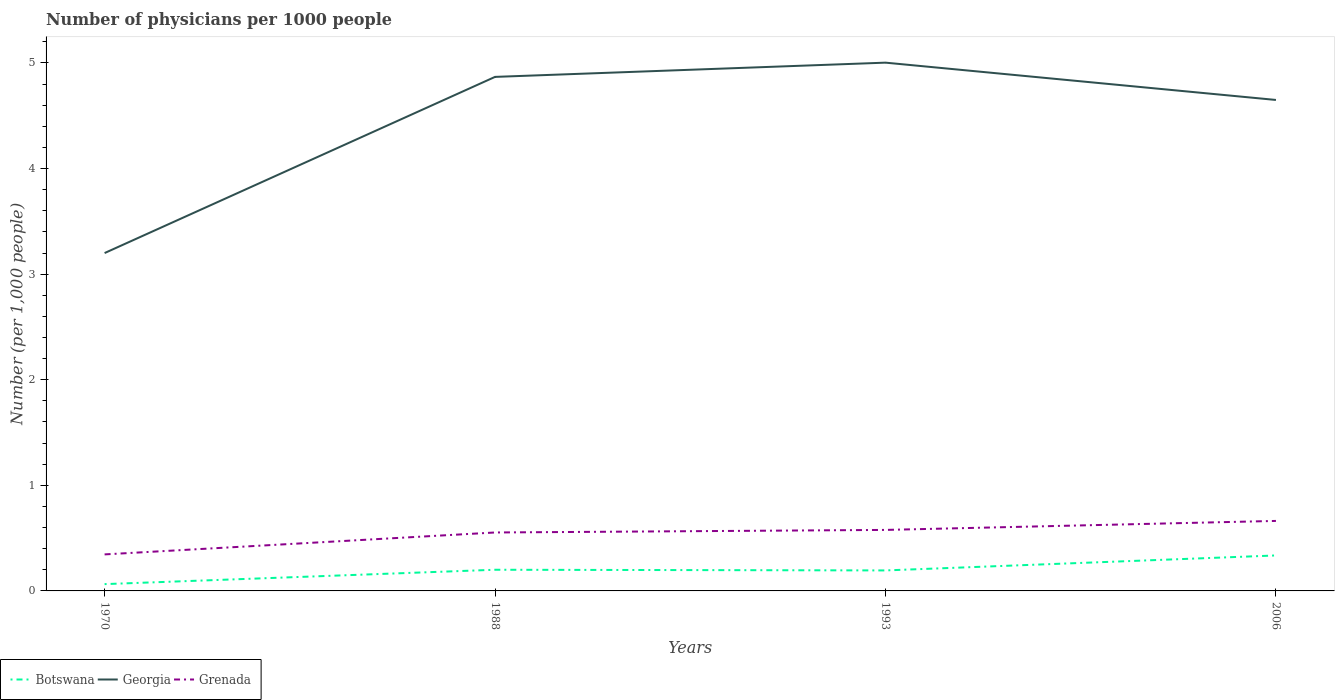How many different coloured lines are there?
Your answer should be compact. 3. Does the line corresponding to Grenada intersect with the line corresponding to Botswana?
Your answer should be compact. No. Is the number of lines equal to the number of legend labels?
Give a very brief answer. Yes. Across all years, what is the maximum number of physicians in Grenada?
Your answer should be very brief. 0.35. What is the total number of physicians in Georgia in the graph?
Give a very brief answer. 0.35. What is the difference between the highest and the second highest number of physicians in Botswana?
Your answer should be very brief. 0.27. How many lines are there?
Offer a very short reply. 3. How many years are there in the graph?
Offer a very short reply. 4. What is the difference between two consecutive major ticks on the Y-axis?
Keep it short and to the point. 1. How many legend labels are there?
Give a very brief answer. 3. How are the legend labels stacked?
Your answer should be very brief. Horizontal. What is the title of the graph?
Provide a succinct answer. Number of physicians per 1000 people. What is the label or title of the X-axis?
Your response must be concise. Years. What is the label or title of the Y-axis?
Your response must be concise. Number (per 1,0 people). What is the Number (per 1,000 people) in Botswana in 1970?
Keep it short and to the point. 0.06. What is the Number (per 1,000 people) in Georgia in 1970?
Provide a short and direct response. 3.2. What is the Number (per 1,000 people) of Grenada in 1970?
Give a very brief answer. 0.35. What is the Number (per 1,000 people) of Botswana in 1988?
Keep it short and to the point. 0.2. What is the Number (per 1,000 people) in Georgia in 1988?
Offer a terse response. 4.87. What is the Number (per 1,000 people) of Grenada in 1988?
Keep it short and to the point. 0.55. What is the Number (per 1,000 people) of Botswana in 1993?
Give a very brief answer. 0.19. What is the Number (per 1,000 people) in Georgia in 1993?
Your answer should be very brief. 5. What is the Number (per 1,000 people) of Grenada in 1993?
Offer a very short reply. 0.58. What is the Number (per 1,000 people) of Botswana in 2006?
Your answer should be compact. 0.34. What is the Number (per 1,000 people) of Georgia in 2006?
Your answer should be compact. 4.65. What is the Number (per 1,000 people) of Grenada in 2006?
Offer a terse response. 0.66. Across all years, what is the maximum Number (per 1,000 people) of Botswana?
Your response must be concise. 0.34. Across all years, what is the maximum Number (per 1,000 people) in Georgia?
Your response must be concise. 5. Across all years, what is the maximum Number (per 1,000 people) of Grenada?
Ensure brevity in your answer.  0.66. Across all years, what is the minimum Number (per 1,000 people) of Botswana?
Ensure brevity in your answer.  0.06. Across all years, what is the minimum Number (per 1,000 people) in Georgia?
Keep it short and to the point. 3.2. Across all years, what is the minimum Number (per 1,000 people) in Grenada?
Provide a succinct answer. 0.35. What is the total Number (per 1,000 people) in Botswana in the graph?
Give a very brief answer. 0.8. What is the total Number (per 1,000 people) in Georgia in the graph?
Provide a succinct answer. 17.72. What is the total Number (per 1,000 people) in Grenada in the graph?
Your answer should be compact. 2.14. What is the difference between the Number (per 1,000 people) in Botswana in 1970 and that in 1988?
Your response must be concise. -0.14. What is the difference between the Number (per 1,000 people) in Georgia in 1970 and that in 1988?
Provide a short and direct response. -1.67. What is the difference between the Number (per 1,000 people) in Grenada in 1970 and that in 1988?
Your response must be concise. -0.21. What is the difference between the Number (per 1,000 people) of Botswana in 1970 and that in 1993?
Your answer should be compact. -0.13. What is the difference between the Number (per 1,000 people) of Georgia in 1970 and that in 1993?
Offer a very short reply. -1.8. What is the difference between the Number (per 1,000 people) of Grenada in 1970 and that in 1993?
Ensure brevity in your answer.  -0.23. What is the difference between the Number (per 1,000 people) of Botswana in 1970 and that in 2006?
Offer a terse response. -0.27. What is the difference between the Number (per 1,000 people) of Georgia in 1970 and that in 2006?
Your response must be concise. -1.45. What is the difference between the Number (per 1,000 people) in Grenada in 1970 and that in 2006?
Provide a short and direct response. -0.32. What is the difference between the Number (per 1,000 people) of Botswana in 1988 and that in 1993?
Provide a short and direct response. 0.01. What is the difference between the Number (per 1,000 people) in Georgia in 1988 and that in 1993?
Provide a short and direct response. -0.13. What is the difference between the Number (per 1,000 people) in Grenada in 1988 and that in 1993?
Ensure brevity in your answer.  -0.02. What is the difference between the Number (per 1,000 people) in Botswana in 1988 and that in 2006?
Your answer should be compact. -0.14. What is the difference between the Number (per 1,000 people) in Georgia in 1988 and that in 2006?
Offer a very short reply. 0.22. What is the difference between the Number (per 1,000 people) in Grenada in 1988 and that in 2006?
Give a very brief answer. -0.11. What is the difference between the Number (per 1,000 people) of Botswana in 1993 and that in 2006?
Your answer should be compact. -0.14. What is the difference between the Number (per 1,000 people) in Georgia in 1993 and that in 2006?
Ensure brevity in your answer.  0.35. What is the difference between the Number (per 1,000 people) in Grenada in 1993 and that in 2006?
Provide a short and direct response. -0.09. What is the difference between the Number (per 1,000 people) of Botswana in 1970 and the Number (per 1,000 people) of Georgia in 1988?
Provide a short and direct response. -4.8. What is the difference between the Number (per 1,000 people) of Botswana in 1970 and the Number (per 1,000 people) of Grenada in 1988?
Your answer should be compact. -0.49. What is the difference between the Number (per 1,000 people) in Georgia in 1970 and the Number (per 1,000 people) in Grenada in 1988?
Provide a succinct answer. 2.65. What is the difference between the Number (per 1,000 people) in Botswana in 1970 and the Number (per 1,000 people) in Georgia in 1993?
Provide a short and direct response. -4.94. What is the difference between the Number (per 1,000 people) of Botswana in 1970 and the Number (per 1,000 people) of Grenada in 1993?
Keep it short and to the point. -0.51. What is the difference between the Number (per 1,000 people) of Georgia in 1970 and the Number (per 1,000 people) of Grenada in 1993?
Make the answer very short. 2.62. What is the difference between the Number (per 1,000 people) in Botswana in 1970 and the Number (per 1,000 people) in Georgia in 2006?
Ensure brevity in your answer.  -4.59. What is the difference between the Number (per 1,000 people) of Botswana in 1970 and the Number (per 1,000 people) of Grenada in 2006?
Provide a short and direct response. -0.6. What is the difference between the Number (per 1,000 people) in Georgia in 1970 and the Number (per 1,000 people) in Grenada in 2006?
Your answer should be compact. 2.54. What is the difference between the Number (per 1,000 people) of Botswana in 1988 and the Number (per 1,000 people) of Georgia in 1993?
Make the answer very short. -4.8. What is the difference between the Number (per 1,000 people) in Botswana in 1988 and the Number (per 1,000 people) in Grenada in 1993?
Offer a very short reply. -0.38. What is the difference between the Number (per 1,000 people) in Georgia in 1988 and the Number (per 1,000 people) in Grenada in 1993?
Give a very brief answer. 4.29. What is the difference between the Number (per 1,000 people) of Botswana in 1988 and the Number (per 1,000 people) of Georgia in 2006?
Your answer should be very brief. -4.45. What is the difference between the Number (per 1,000 people) of Botswana in 1988 and the Number (per 1,000 people) of Grenada in 2006?
Offer a very short reply. -0.46. What is the difference between the Number (per 1,000 people) in Georgia in 1988 and the Number (per 1,000 people) in Grenada in 2006?
Keep it short and to the point. 4.21. What is the difference between the Number (per 1,000 people) of Botswana in 1993 and the Number (per 1,000 people) of Georgia in 2006?
Your response must be concise. -4.46. What is the difference between the Number (per 1,000 people) in Botswana in 1993 and the Number (per 1,000 people) in Grenada in 2006?
Give a very brief answer. -0.47. What is the difference between the Number (per 1,000 people) of Georgia in 1993 and the Number (per 1,000 people) of Grenada in 2006?
Offer a very short reply. 4.34. What is the average Number (per 1,000 people) of Botswana per year?
Offer a very short reply. 0.2. What is the average Number (per 1,000 people) of Georgia per year?
Provide a short and direct response. 4.43. What is the average Number (per 1,000 people) of Grenada per year?
Offer a very short reply. 0.54. In the year 1970, what is the difference between the Number (per 1,000 people) of Botswana and Number (per 1,000 people) of Georgia?
Give a very brief answer. -3.14. In the year 1970, what is the difference between the Number (per 1,000 people) of Botswana and Number (per 1,000 people) of Grenada?
Provide a succinct answer. -0.28. In the year 1970, what is the difference between the Number (per 1,000 people) of Georgia and Number (per 1,000 people) of Grenada?
Your response must be concise. 2.85. In the year 1988, what is the difference between the Number (per 1,000 people) in Botswana and Number (per 1,000 people) in Georgia?
Make the answer very short. -4.67. In the year 1988, what is the difference between the Number (per 1,000 people) of Botswana and Number (per 1,000 people) of Grenada?
Give a very brief answer. -0.35. In the year 1988, what is the difference between the Number (per 1,000 people) in Georgia and Number (per 1,000 people) in Grenada?
Provide a succinct answer. 4.31. In the year 1993, what is the difference between the Number (per 1,000 people) in Botswana and Number (per 1,000 people) in Georgia?
Provide a short and direct response. -4.81. In the year 1993, what is the difference between the Number (per 1,000 people) of Botswana and Number (per 1,000 people) of Grenada?
Give a very brief answer. -0.38. In the year 1993, what is the difference between the Number (per 1,000 people) in Georgia and Number (per 1,000 people) in Grenada?
Your answer should be very brief. 4.43. In the year 2006, what is the difference between the Number (per 1,000 people) in Botswana and Number (per 1,000 people) in Georgia?
Make the answer very short. -4.31. In the year 2006, what is the difference between the Number (per 1,000 people) in Botswana and Number (per 1,000 people) in Grenada?
Provide a short and direct response. -0.33. In the year 2006, what is the difference between the Number (per 1,000 people) in Georgia and Number (per 1,000 people) in Grenada?
Make the answer very short. 3.99. What is the ratio of the Number (per 1,000 people) in Botswana in 1970 to that in 1988?
Give a very brief answer. 0.32. What is the ratio of the Number (per 1,000 people) in Georgia in 1970 to that in 1988?
Ensure brevity in your answer.  0.66. What is the ratio of the Number (per 1,000 people) of Grenada in 1970 to that in 1988?
Give a very brief answer. 0.62. What is the ratio of the Number (per 1,000 people) in Botswana in 1970 to that in 1993?
Your answer should be compact. 0.33. What is the ratio of the Number (per 1,000 people) of Georgia in 1970 to that in 1993?
Make the answer very short. 0.64. What is the ratio of the Number (per 1,000 people) of Grenada in 1970 to that in 1993?
Provide a succinct answer. 0.6. What is the ratio of the Number (per 1,000 people) of Botswana in 1970 to that in 2006?
Make the answer very short. 0.19. What is the ratio of the Number (per 1,000 people) in Georgia in 1970 to that in 2006?
Provide a short and direct response. 0.69. What is the ratio of the Number (per 1,000 people) in Grenada in 1970 to that in 2006?
Make the answer very short. 0.52. What is the ratio of the Number (per 1,000 people) of Botswana in 1988 to that in 1993?
Keep it short and to the point. 1.03. What is the ratio of the Number (per 1,000 people) of Grenada in 1988 to that in 1993?
Your answer should be very brief. 0.96. What is the ratio of the Number (per 1,000 people) of Botswana in 1988 to that in 2006?
Keep it short and to the point. 0.6. What is the ratio of the Number (per 1,000 people) in Georgia in 1988 to that in 2006?
Offer a terse response. 1.05. What is the ratio of the Number (per 1,000 people) in Grenada in 1988 to that in 2006?
Keep it short and to the point. 0.83. What is the ratio of the Number (per 1,000 people) in Botswana in 1993 to that in 2006?
Provide a short and direct response. 0.58. What is the ratio of the Number (per 1,000 people) in Georgia in 1993 to that in 2006?
Provide a succinct answer. 1.08. What is the ratio of the Number (per 1,000 people) of Grenada in 1993 to that in 2006?
Provide a short and direct response. 0.87. What is the difference between the highest and the second highest Number (per 1,000 people) of Botswana?
Your answer should be very brief. 0.14. What is the difference between the highest and the second highest Number (per 1,000 people) in Georgia?
Provide a short and direct response. 0.13. What is the difference between the highest and the second highest Number (per 1,000 people) in Grenada?
Offer a terse response. 0.09. What is the difference between the highest and the lowest Number (per 1,000 people) in Botswana?
Your answer should be compact. 0.27. What is the difference between the highest and the lowest Number (per 1,000 people) in Georgia?
Make the answer very short. 1.8. What is the difference between the highest and the lowest Number (per 1,000 people) in Grenada?
Ensure brevity in your answer.  0.32. 